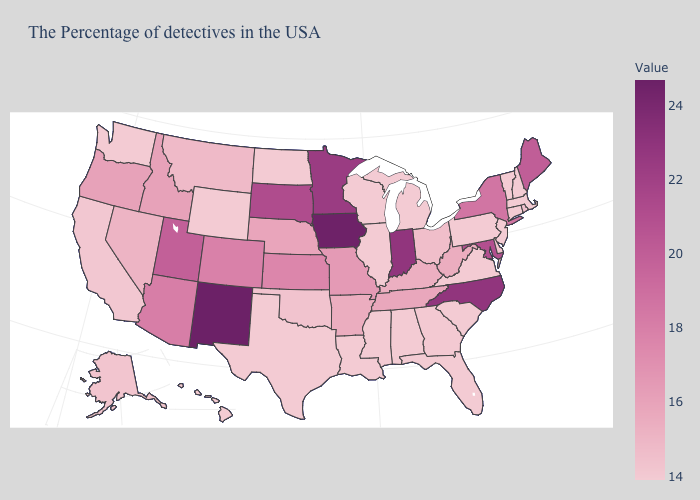Does Wyoming have the lowest value in the USA?
Concise answer only. Yes. Which states hav the highest value in the West?
Quick response, please. New Mexico. Among the states that border Virginia , which have the lowest value?
Write a very short answer. Kentucky. Does Rhode Island have the lowest value in the USA?
Short answer required. No. Does the map have missing data?
Answer briefly. No. Which states have the highest value in the USA?
Keep it brief. New Mexico. 